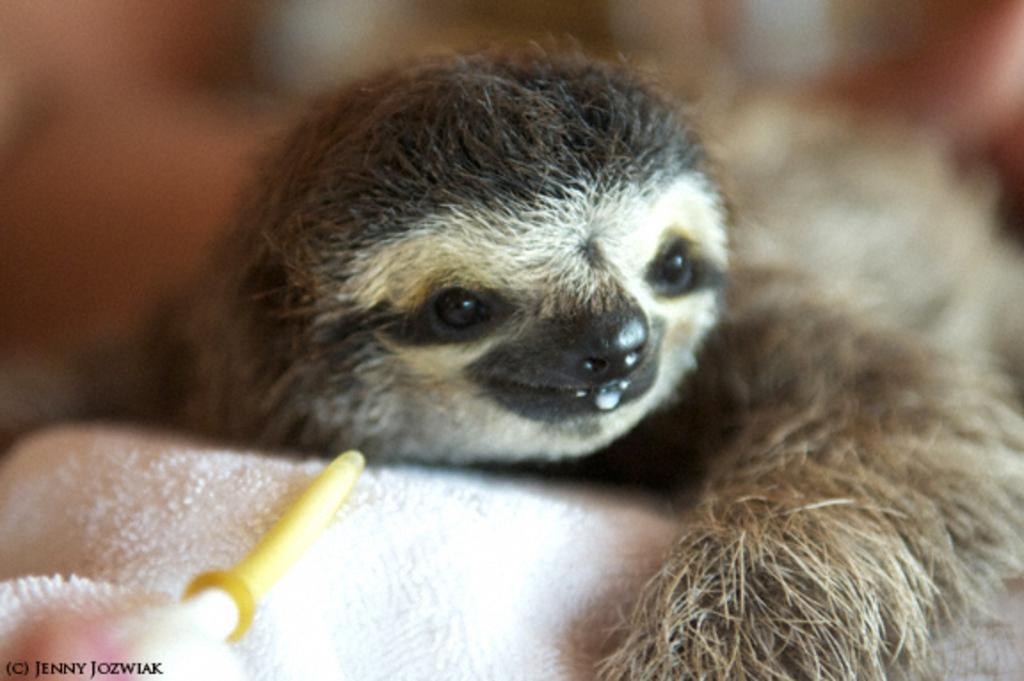What animal is the main subject of the image? There is a sloth in the image. What is the sloth resting on? The sloth is on a white cloth. Can you describe the background of the image? The background of the image is blurred. How many rings does the duck have in the image? There is no duck present in the image, and therefore no rings can be associated with it. 